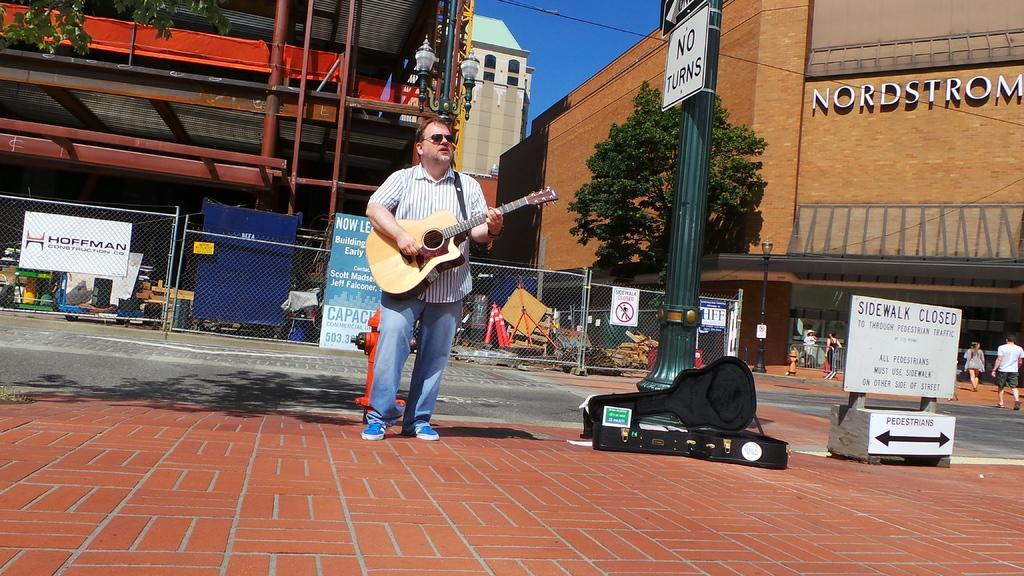Describe this image in one or two sentences. In the center we can see one man standing and holding guitar. And coming to the background we can see building named as "Cord Storm". And we can see fence,some sign boards,traffic pole,street light and few persons were walking on the road,trees,sky etc. 